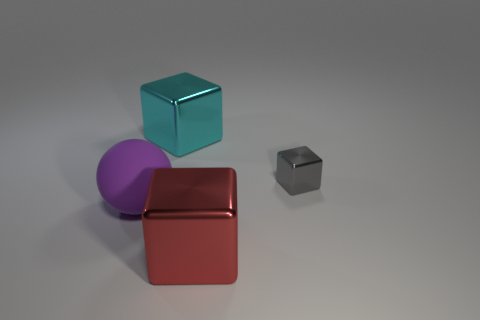Is there any other thing that is made of the same material as the sphere?
Your answer should be compact. No. There is a thing that is on the left side of the big red metal thing and in front of the gray metallic block; what is its shape?
Ensure brevity in your answer.  Sphere. How many things are metal things that are left of the small shiny object or big things that are on the right side of the large ball?
Make the answer very short. 2. What number of other objects are the same size as the red metallic cube?
Keep it short and to the point. 2. What is the size of the thing that is both in front of the small gray thing and right of the matte ball?
Offer a very short reply. Large. What number of large objects are either red cubes or cyan metallic blocks?
Your answer should be compact. 2. There is a big metal thing in front of the cyan metal thing; what shape is it?
Keep it short and to the point. Cube. What number of tiny purple matte cylinders are there?
Ensure brevity in your answer.  0. Do the small gray block and the large cyan object have the same material?
Provide a succinct answer. Yes. Is the number of large things behind the small shiny block greater than the number of tiny blue matte cylinders?
Make the answer very short. Yes. 